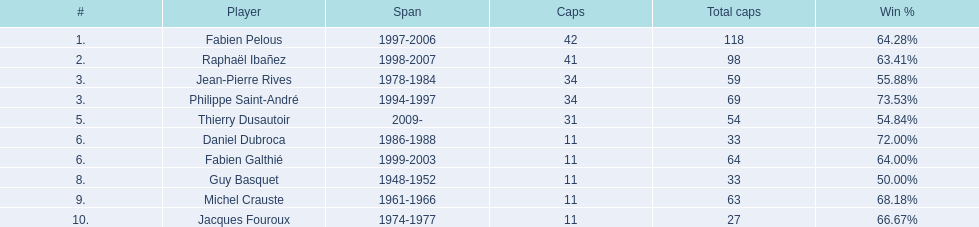How long did fabien pelous serve as captain in the french national rugby team? 9 years. 